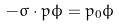<formula> <loc_0><loc_0><loc_500><loc_500>- \sigma \cdot { p } \phi = p _ { 0 } \phi</formula> 